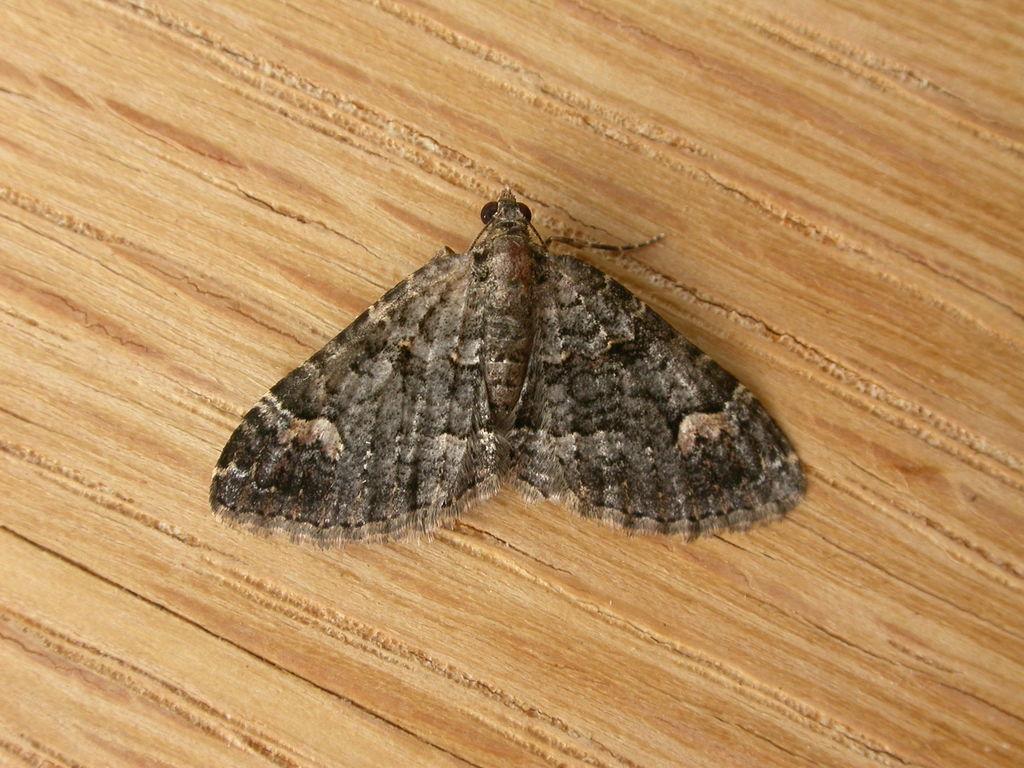Describe this image in one or two sentences. In this image we can see a butterfly on the wooden surface. 